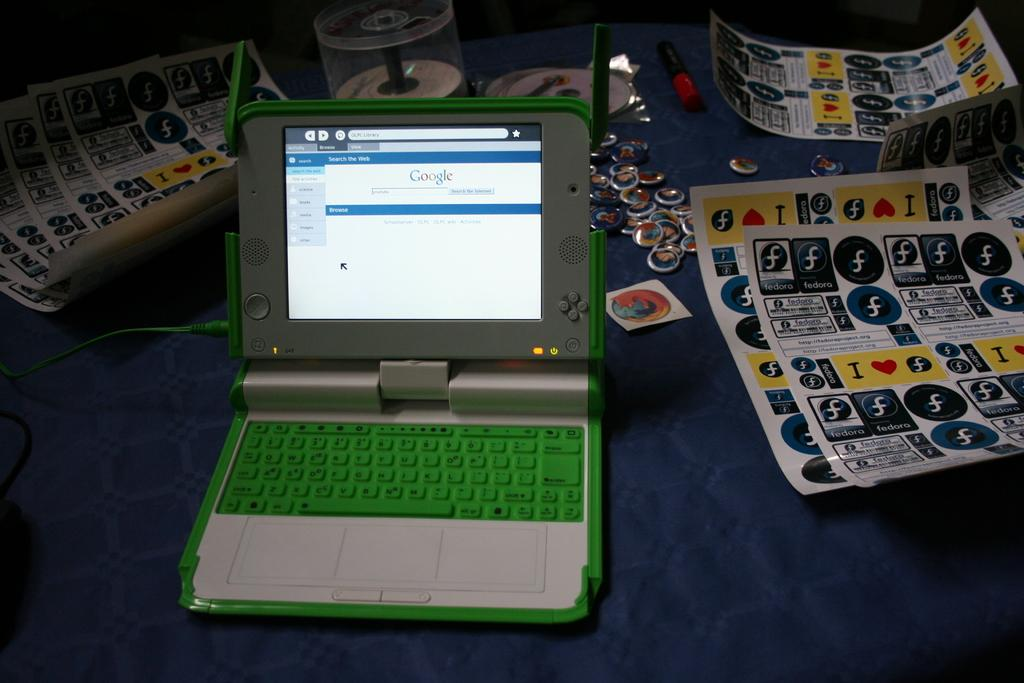<image>
Provide a brief description of the given image. A small laptop with a green keyboard is open to Google's webpage. 